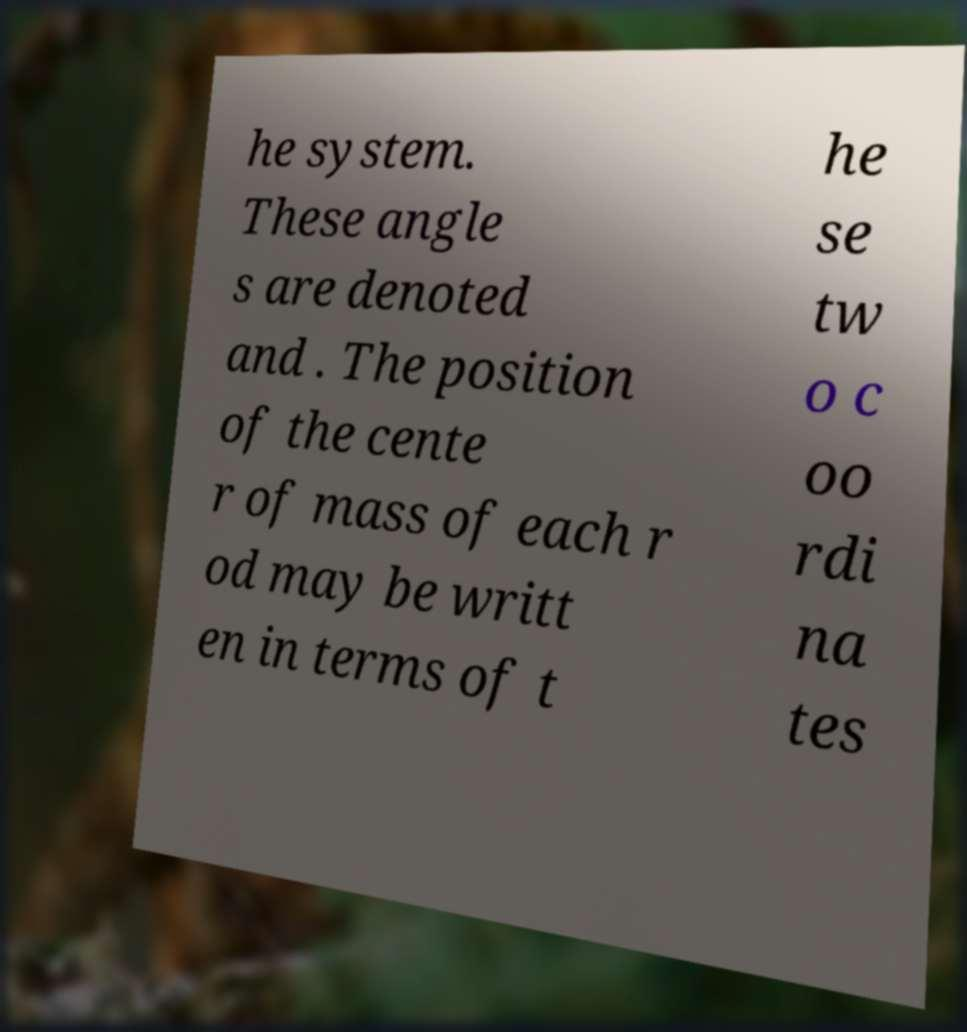Could you extract and type out the text from this image? he system. These angle s are denoted and . The position of the cente r of mass of each r od may be writt en in terms of t he se tw o c oo rdi na tes 